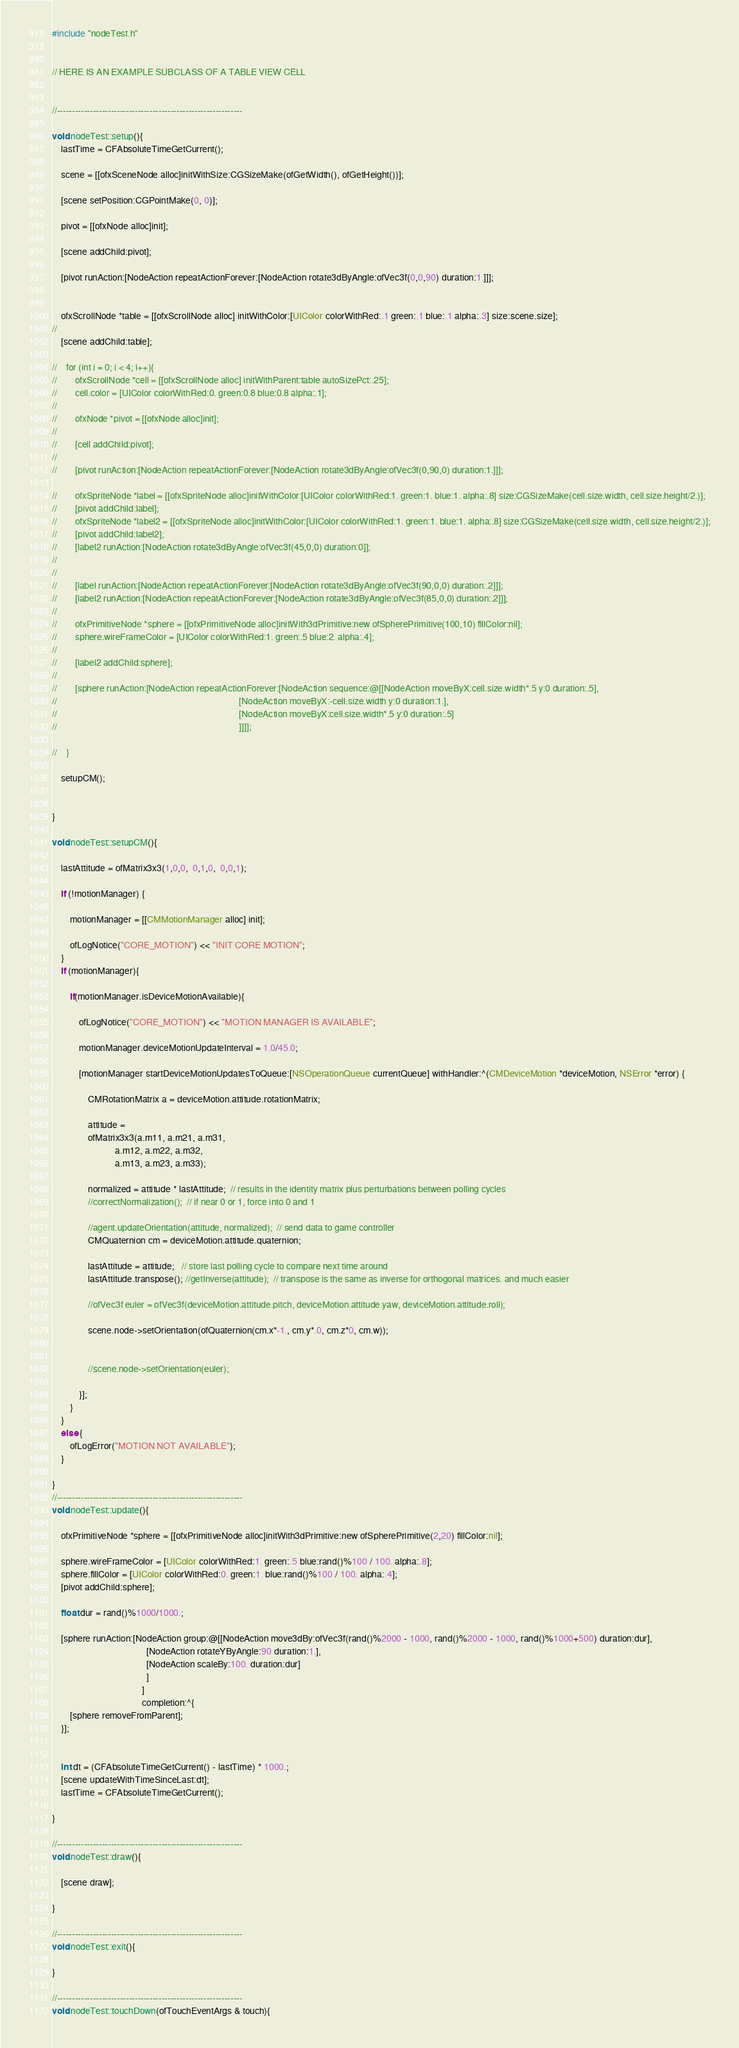Convert code to text. <code><loc_0><loc_0><loc_500><loc_500><_ObjectiveC_>#include "nodeTest.h"


// HERE IS AN EXAMPLE SUBCLASS OF A TABLE VIEW CELL


//--------------------------------------------------------------

void nodeTest::setup(){
    lastTime = CFAbsoluteTimeGetCurrent();
    
    scene = [[ofxSceneNode alloc]initWithSize:CGSizeMake(ofGetWidth(), ofGetHeight())];
    
    [scene setPosition:CGPointMake(0, 0)];
    
    pivot = [[ofxNode alloc]init];
    
    [scene addChild:pivot];
    
    [pivot runAction:[NodeAction repeatActionForever:[NodeAction rotate3dByAngle:ofVec3f(0,0,90) duration:1.]]];
    
  
    ofxScrollNode *table = [[ofxScrollNode alloc] initWithColor:[UIColor colorWithRed:.1 green:.1 blue:.1 alpha:.3] size:scene.size];
//    
    [scene addChild:table];

//    for (int i = 0; i < 4; i++){
//        ofxScrollNode *cell = [[ofxScrollNode alloc] initWithParent:table autoSizePct:.25];
//        cell.color = [UIColor colorWithRed:0. green:0.8 blue:0.8 alpha:.1];
//        
//        ofxNode *pivot = [[ofxNode alloc]init];
//        
//        [cell addChild:pivot];
//        
//        [pivot runAction:[NodeAction repeatActionForever:[NodeAction rotate3dByAngle:ofVec3f(0,90,0) duration:1.]]];
    
//        ofxSpriteNode *label = [[ofxSpriteNode alloc]initWithColor:[UIColor colorWithRed:1. green:1. blue:1. alpha:.8] size:CGSizeMake(cell.size.width, cell.size.height/2.)];
//        [pivot addChild:label];
//        ofxSpriteNode *label2 = [[ofxSpriteNode alloc]initWithColor:[UIColor colorWithRed:1. green:1. blue:1. alpha:.8] size:CGSizeMake(cell.size.width, cell.size.height/2.)];
//        [pivot addChild:label2];
//        [label2 runAction:[NodeAction rotate3dByAngle:ofVec3f(45,0,0) duration:0]];
//        
//       
//        [label runAction:[NodeAction repeatActionForever:[NodeAction rotate3dByAngle:ofVec3f(90,0,0) duration:.2]]];
//        [label2 runAction:[NodeAction repeatActionForever:[NodeAction rotate3dByAngle:ofVec3f(85,0,0) duration:.2]]];
//
//        ofxPrimitiveNode *sphere = [[ofxPrimitiveNode alloc]initWith3dPrimitive:new ofSpherePrimitive(100,10) fillColor:nil];
//        sphere.wireFrameColor = [UIColor colorWithRed:1. green:.5 blue:2. alpha:.4];
//        
//        [label2 addChild:sphere];
//        
//        [sphere runAction:[NodeAction repeatActionForever:[NodeAction sequence:@[[NodeAction moveByX:cell.size.width*.5 y:0 duration:.5],
//                                                                                 [NodeAction moveByX:-cell.size.width y:0 duration:1.],
//                                                                                 [NodeAction moveByX:cell.size.width*.5 y:0 duration:.5]
//                                                                                 ]]]];
        
//    }
    
    setupCM();
   

}

void nodeTest::setupCM(){
 
    lastAttitude = ofMatrix3x3(1,0,0,  0,1,0,  0,0,1);
    
    if (!motionManager) {
        
        motionManager = [[CMMotionManager alloc] init];
        
        ofLogNotice("CORE_MOTION") << "INIT CORE MOTION";
    }
    if (motionManager){
        
        if(motionManager.isDeviceMotionAvailable){
            
            ofLogNotice("CORE_MOTION") << "MOTION MANAGER IS AVAILABLE";
            
            motionManager.deviceMotionUpdateInterval = 1.0/45.0;
            
            [motionManager startDeviceMotionUpdatesToQueue:[NSOperationQueue currentQueue] withHandler:^(CMDeviceMotion *deviceMotion, NSError *error) {
                
                CMRotationMatrix a = deviceMotion.attitude.rotationMatrix;
                
                attitude =
                ofMatrix3x3(a.m11, a.m21, a.m31,
                            a.m12, a.m22, a.m32,
                            a.m13, a.m23, a.m33);
                
                normalized = attitude * lastAttitude;  // results in the identity matrix plus perturbations between polling cycles
                //correctNormalization();  // if near 0 or 1, force into 0 and 1
                
                //agent.updateOrientation(attitude, normalized);  // send data to game controller
                CMQuaternion cm = deviceMotion.attitude.quaternion;
                
                lastAttitude = attitude;   // store last polling cycle to compare next time around
                lastAttitude.transpose(); //getInverse(attitude);  // transpose is the same as inverse for orthogonal matrices. and much easier
                
                //ofVec3f euler = ofVec3f(deviceMotion.attitude.pitch, deviceMotion.attitude.yaw, deviceMotion.attitude.roll);
                
                scene.node->setOrientation(ofQuaternion(cm.x*-1., cm.y*.0, cm.z*0, cm.w));
                
                
                //scene.node->setOrientation(euler);
                
            }];
        }
    }
    else {
        ofLogError("MOTION NOT AVAILABLE");
    }
    
}
//--------------------------------------------------------------
void nodeTest::update(){
    
    ofxPrimitiveNode *sphere = [[ofxPrimitiveNode alloc]initWith3dPrimitive:new ofSpherePrimitive(2,20) fillColor:nil];
    
    sphere.wireFrameColor = [UIColor colorWithRed:1. green:.5 blue:rand()%100 / 100. alpha:.8];
    sphere.fillColor = [UIColor colorWithRed:0. green:1. blue:rand()%100 / 100. alpha:.4];
    [pivot addChild:sphere];
    
    float dur = rand()%1000/1000.;

    [sphere runAction:[NodeAction group:@[[NodeAction move3dBy:ofVec3f(rand()%2000 - 1000, rand()%2000 - 1000, rand()%1000+500) duration:dur],
                                          [NodeAction rotateYByAngle:90 duration:1.],
                                          [NodeAction scaleBy:100. duration:dur]
                                          ]
                                        ]
                                        completion:^{
        [sphere removeFromParent];
    }];

    
    int dt = (CFAbsoluteTimeGetCurrent() - lastTime) * 1000.;
    [scene updateWithTimeSinceLast:dt];
    lastTime = CFAbsoluteTimeGetCurrent();
    
}

//--------------------------------------------------------------
void nodeTest::draw(){

    [scene draw];

}

//--------------------------------------------------------------
void nodeTest::exit(){
    
}

//--------------------------------------------------------------
void nodeTest::touchDown(ofTouchEventArgs & touch){</code> 